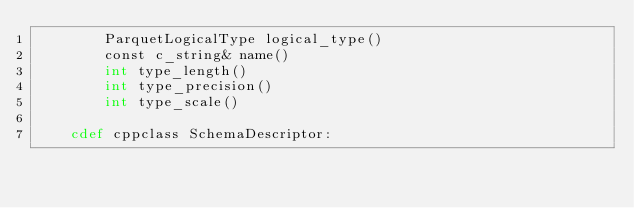<code> <loc_0><loc_0><loc_500><loc_500><_Cython_>        ParquetLogicalType logical_type()
        const c_string& name()
        int type_length()
        int type_precision()
        int type_scale()

    cdef cppclass SchemaDescriptor:</code> 